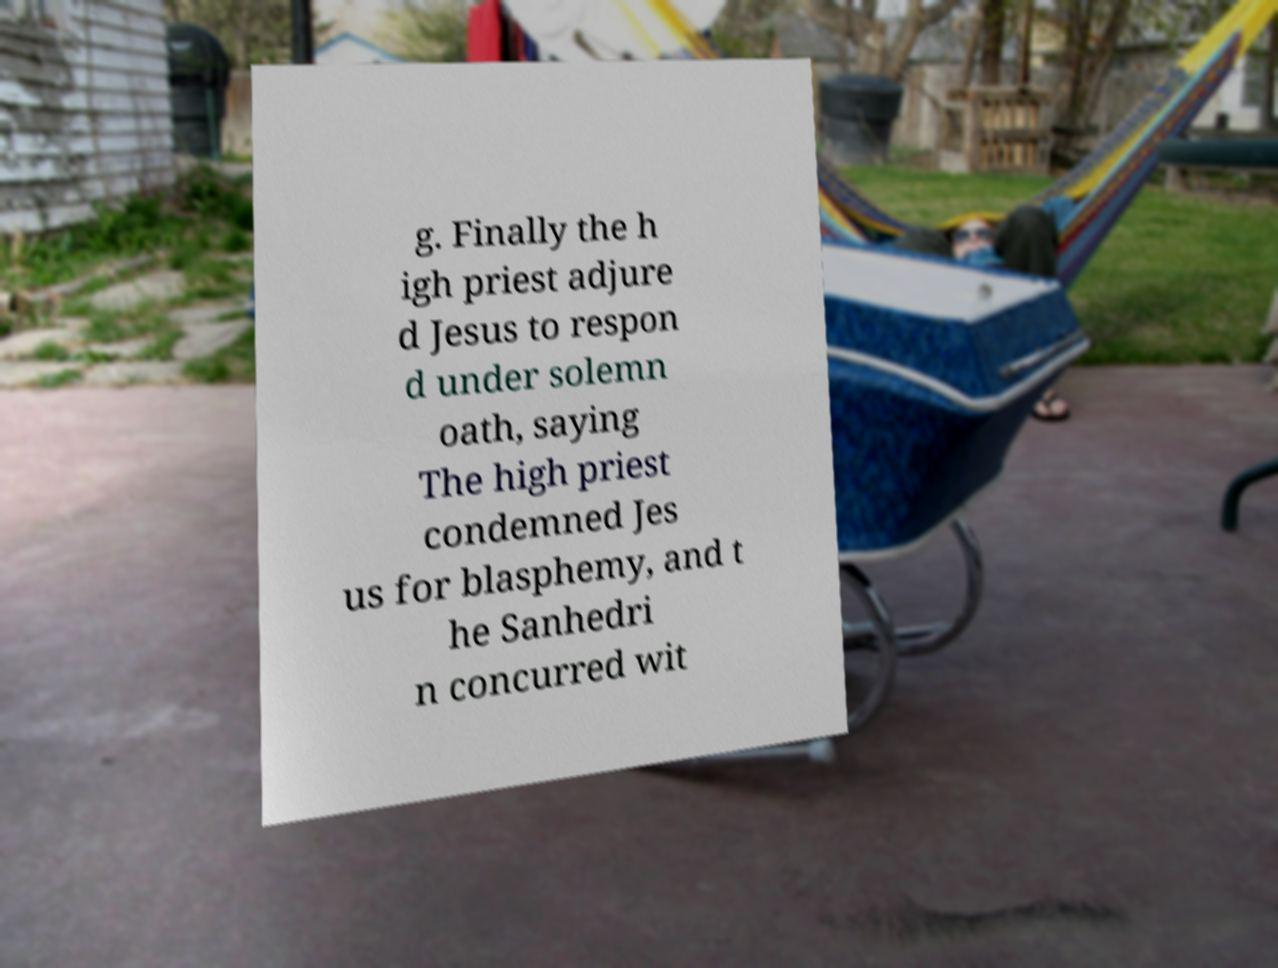Could you extract and type out the text from this image? g. Finally the h igh priest adjure d Jesus to respon d under solemn oath, saying The high priest condemned Jes us for blasphemy, and t he Sanhedri n concurred wit 